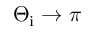Convert formula to latex. <formula><loc_0><loc_0><loc_500><loc_500>\Theta _ { i } \to \pi</formula> 